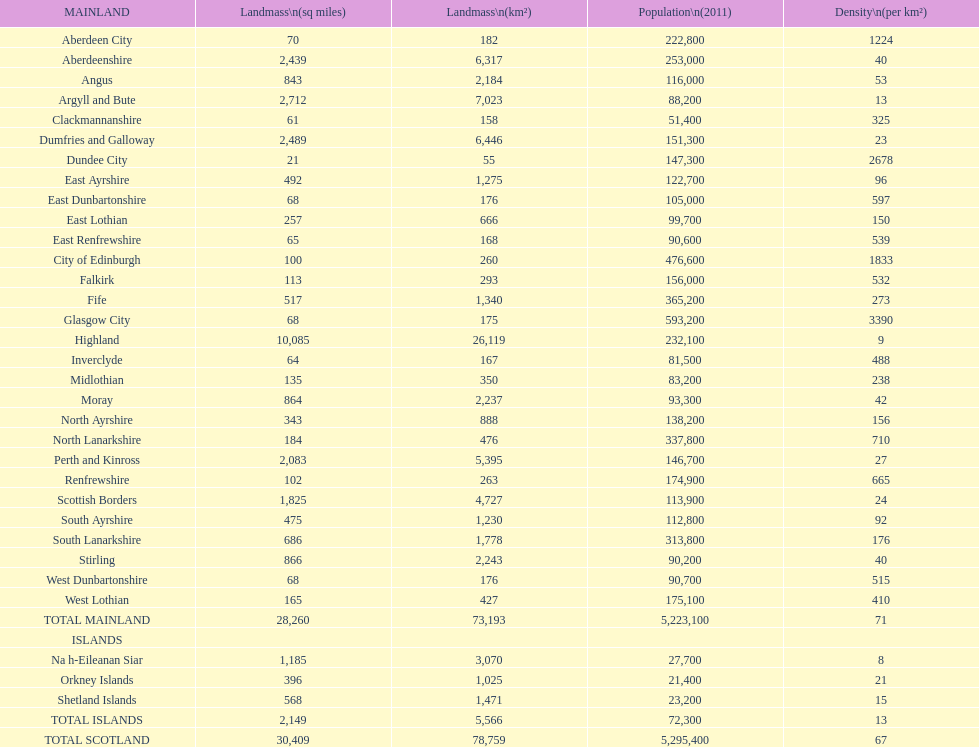What is the total area of east lothian, angus, and dundee city? 1121. 